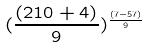Convert formula to latex. <formula><loc_0><loc_0><loc_500><loc_500>( \frac { ( 2 1 0 + 4 ) } { 9 } ) ^ { \frac { ( 7 - 5 7 ) } { 9 } }</formula> 